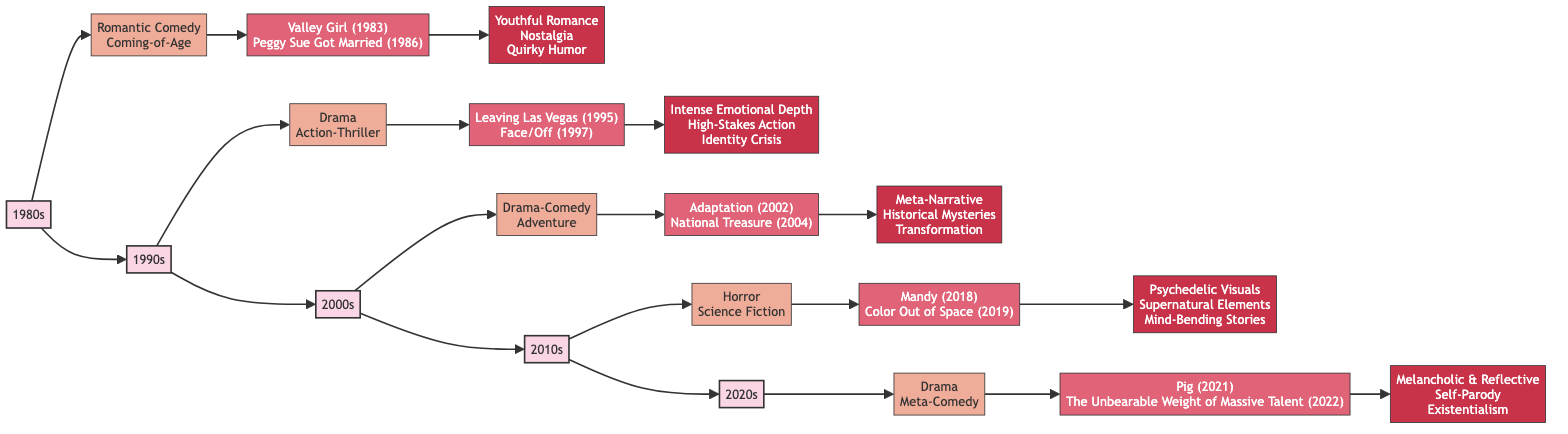What are the key films from the 1990s? The diagram shows the key films for the 1990s, which are connected to the "1990s" node. They are "Leaving Las Vegas (1995)" and "Face/Off (1997)".
Answer: Leaving Las Vegas (1995), Face/Off (1997) How many genres are associated with the 2000s? In the diagram under the "2000s" node, there are two genres listed: "Drama-Comedy" and "Adventure". Therefore, the total count is two.
Answer: 2 Which decade features "Mandy" and "Color Out of Space"? The key films "Mandy (2018)" and "Color Out of Space (2019)" are directly connected to the "2010s" node in the flowchart.
Answer: 2010s What characteristic is linked to the 1980s genre elements? The flowchart indicates that the characteristics linked to the 1980s are "Youthful Romance", "Nostalgia", and "Quirky Humor", which fall under the "1980s" node.
Answer: Youthful Romance, Nostalgia, Quirky Humor How do the genres change from 1980s to 2020s? By tracing the connections through the flowchart, we can observe the genre evolution: the 1980s feature Romantic Comedy and Coming-of-Age, 1990s include Drama and Action-Thriller, 2000s have Drama-Comedy and Adventure, 2010s shift to Horror and Science Fiction, and finally, 2020s focus on Drama and Meta-Comedy. This illustrates the broadening and diversification of genres over time.
Answer: Diverse genres evolve over decades What unique genre characteristic defines films in the 2020s? From the diagram, the unique characteristics associated with films from the 2020s include "Melancholic & Reflective", "Self-Parody", and "Existentialism".
Answer: Melancholic & Reflective, Self-Parody, Existentialism Which decade has the film "Adaptation"? The film "Adaptation (2002)" is specifically listed under the "2000s" node in the flowchart, indicating that it belongs to this decade.
Answer: 2000s What is the last decade represented in the flowchart? Observing the connections leading from the nodes, it is clear that the last node in the horizontal flowchart sequence is "2020s".
Answer: 2020s 